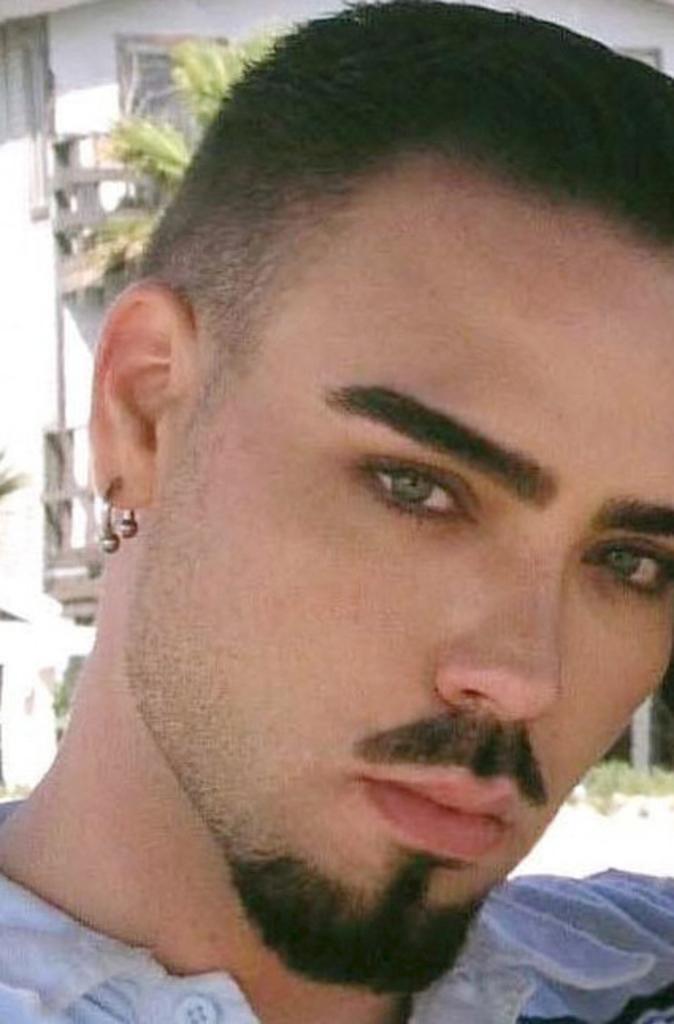Can you describe this image briefly? In the center of the image, we can see a man and in the background, there is a building and we can see a tree. 